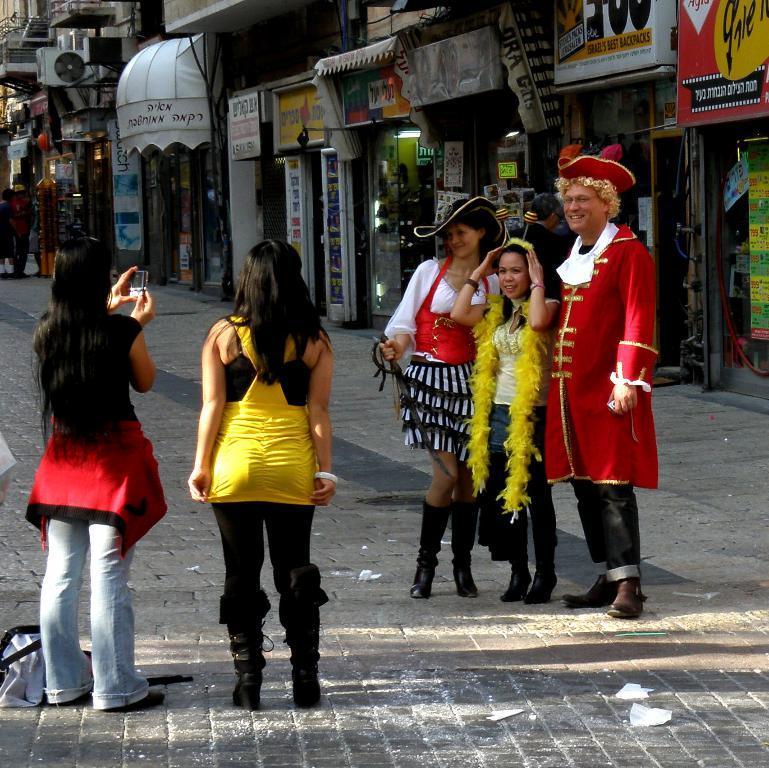In one or two sentences, can you explain what this image depicts? In this picture there are people those who are standing on the right side of the image, it seems to be they are wearing costumes and there is a girl on the left side of the image, she is taking a photograph and there is another girl beside her, there are shops, posters, and other people in the background area of the image. 